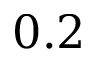Convert formula to latex. <formula><loc_0><loc_0><loc_500><loc_500>0 . 2</formula> 